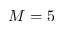<formula> <loc_0><loc_0><loc_500><loc_500>M = 5</formula> 